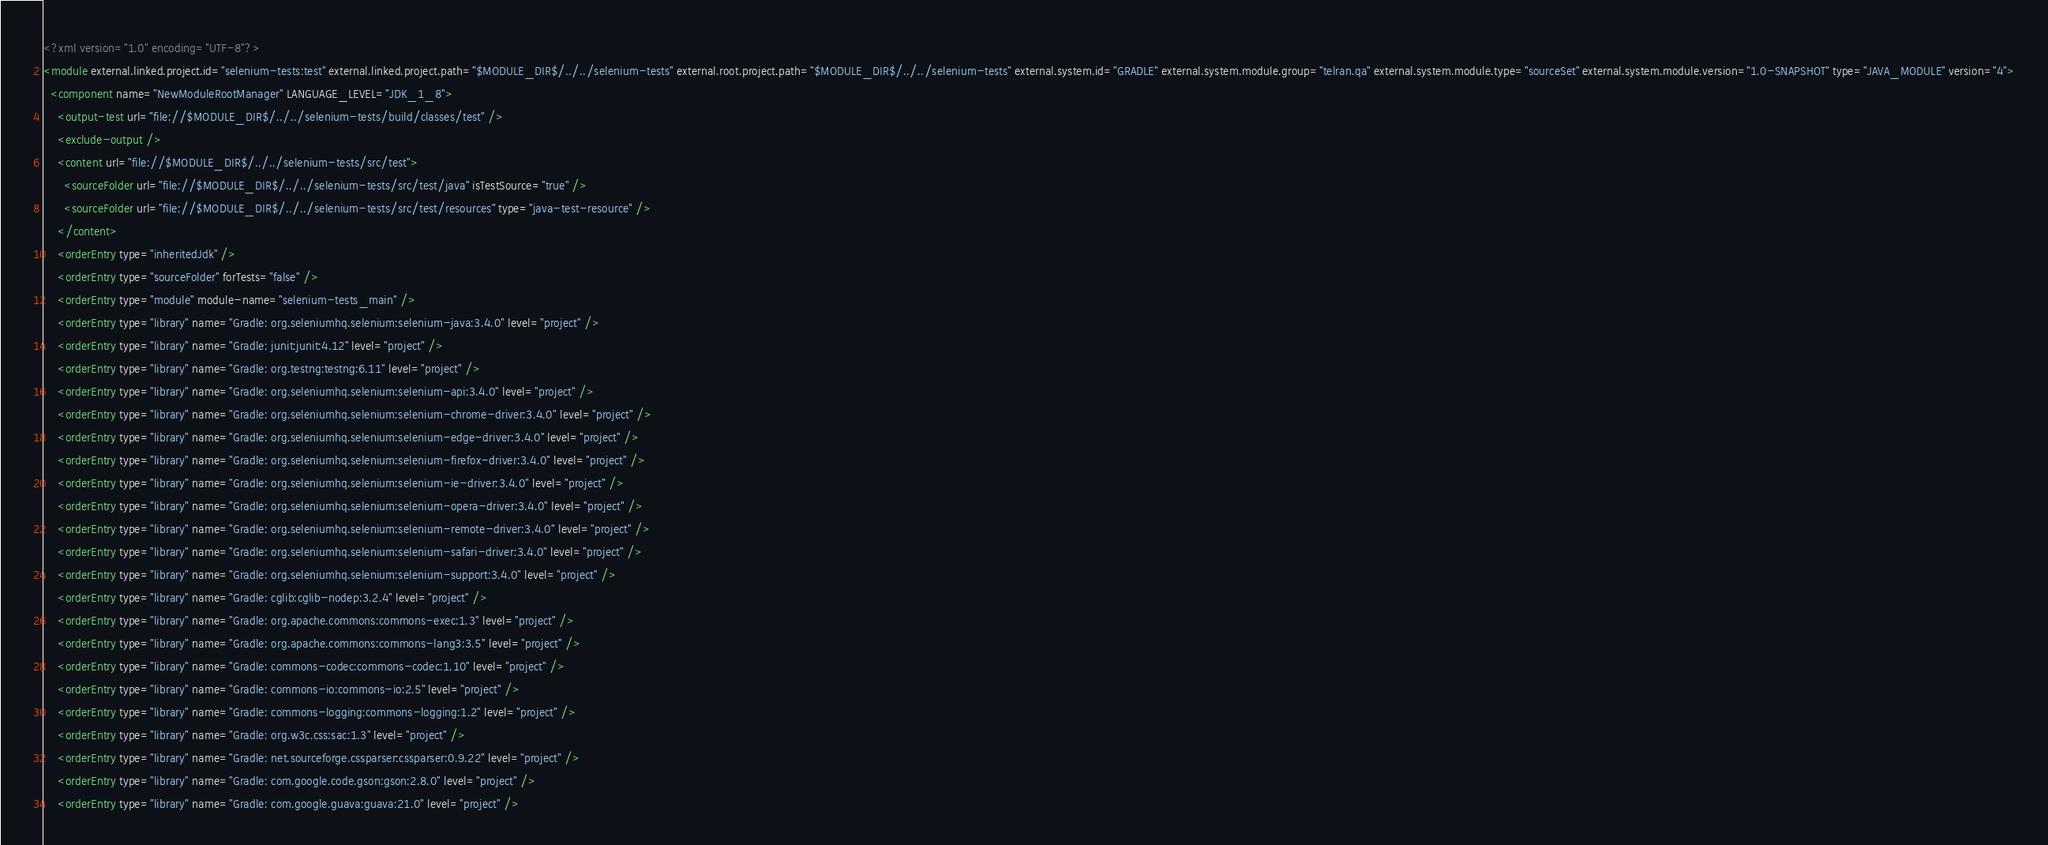Convert code to text. <code><loc_0><loc_0><loc_500><loc_500><_XML_><?xml version="1.0" encoding="UTF-8"?>
<module external.linked.project.id="selenium-tests:test" external.linked.project.path="$MODULE_DIR$/../../selenium-tests" external.root.project.path="$MODULE_DIR$/../../selenium-tests" external.system.id="GRADLE" external.system.module.group="telran.qa" external.system.module.type="sourceSet" external.system.module.version="1.0-SNAPSHOT" type="JAVA_MODULE" version="4">
  <component name="NewModuleRootManager" LANGUAGE_LEVEL="JDK_1_8">
    <output-test url="file://$MODULE_DIR$/../../selenium-tests/build/classes/test" />
    <exclude-output />
    <content url="file://$MODULE_DIR$/../../selenium-tests/src/test">
      <sourceFolder url="file://$MODULE_DIR$/../../selenium-tests/src/test/java" isTestSource="true" />
      <sourceFolder url="file://$MODULE_DIR$/../../selenium-tests/src/test/resources" type="java-test-resource" />
    </content>
    <orderEntry type="inheritedJdk" />
    <orderEntry type="sourceFolder" forTests="false" />
    <orderEntry type="module" module-name="selenium-tests_main" />
    <orderEntry type="library" name="Gradle: org.seleniumhq.selenium:selenium-java:3.4.0" level="project" />
    <orderEntry type="library" name="Gradle: junit:junit:4.12" level="project" />
    <orderEntry type="library" name="Gradle: org.testng:testng:6.11" level="project" />
    <orderEntry type="library" name="Gradle: org.seleniumhq.selenium:selenium-api:3.4.0" level="project" />
    <orderEntry type="library" name="Gradle: org.seleniumhq.selenium:selenium-chrome-driver:3.4.0" level="project" />
    <orderEntry type="library" name="Gradle: org.seleniumhq.selenium:selenium-edge-driver:3.4.0" level="project" />
    <orderEntry type="library" name="Gradle: org.seleniumhq.selenium:selenium-firefox-driver:3.4.0" level="project" />
    <orderEntry type="library" name="Gradle: org.seleniumhq.selenium:selenium-ie-driver:3.4.0" level="project" />
    <orderEntry type="library" name="Gradle: org.seleniumhq.selenium:selenium-opera-driver:3.4.0" level="project" />
    <orderEntry type="library" name="Gradle: org.seleniumhq.selenium:selenium-remote-driver:3.4.0" level="project" />
    <orderEntry type="library" name="Gradle: org.seleniumhq.selenium:selenium-safari-driver:3.4.0" level="project" />
    <orderEntry type="library" name="Gradle: org.seleniumhq.selenium:selenium-support:3.4.0" level="project" />
    <orderEntry type="library" name="Gradle: cglib:cglib-nodep:3.2.4" level="project" />
    <orderEntry type="library" name="Gradle: org.apache.commons:commons-exec:1.3" level="project" />
    <orderEntry type="library" name="Gradle: org.apache.commons:commons-lang3:3.5" level="project" />
    <orderEntry type="library" name="Gradle: commons-codec:commons-codec:1.10" level="project" />
    <orderEntry type="library" name="Gradle: commons-io:commons-io:2.5" level="project" />
    <orderEntry type="library" name="Gradle: commons-logging:commons-logging:1.2" level="project" />
    <orderEntry type="library" name="Gradle: org.w3c.css:sac:1.3" level="project" />
    <orderEntry type="library" name="Gradle: net.sourceforge.cssparser:cssparser:0.9.22" level="project" />
    <orderEntry type="library" name="Gradle: com.google.code.gson:gson:2.8.0" level="project" />
    <orderEntry type="library" name="Gradle: com.google.guava:guava:21.0" level="project" /></code> 